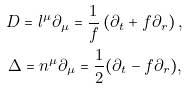Convert formula to latex. <formula><loc_0><loc_0><loc_500><loc_500>D = l ^ { \mu } \partial _ { \mu } = \frac { 1 } { f } \left ( \partial _ { t } + f \partial _ { r } \right ) , \\ \Delta = n ^ { \mu } \partial _ { \mu } = \frac { 1 } { 2 } ( \partial _ { t } - f \partial _ { r } ) ,</formula> 